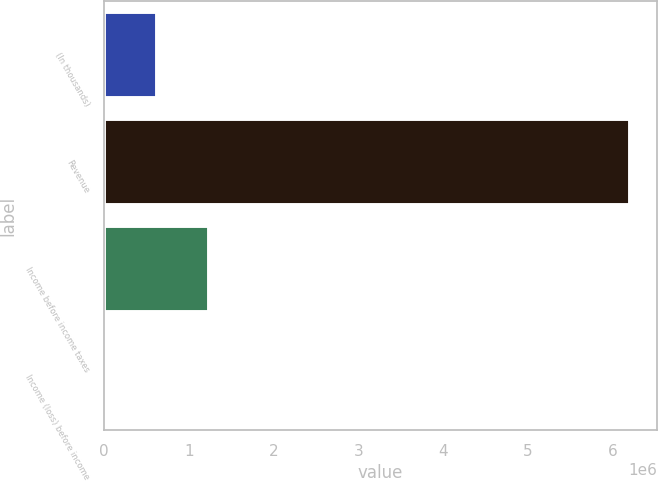Convert chart to OTSL. <chart><loc_0><loc_0><loc_500><loc_500><bar_chart><fcel>(In thousands)<fcel>Revenue<fcel>Income before income taxes<fcel>Income (loss) before income<nl><fcel>621472<fcel>6.20592e+06<fcel>1.24197e+06<fcel>978<nl></chart> 